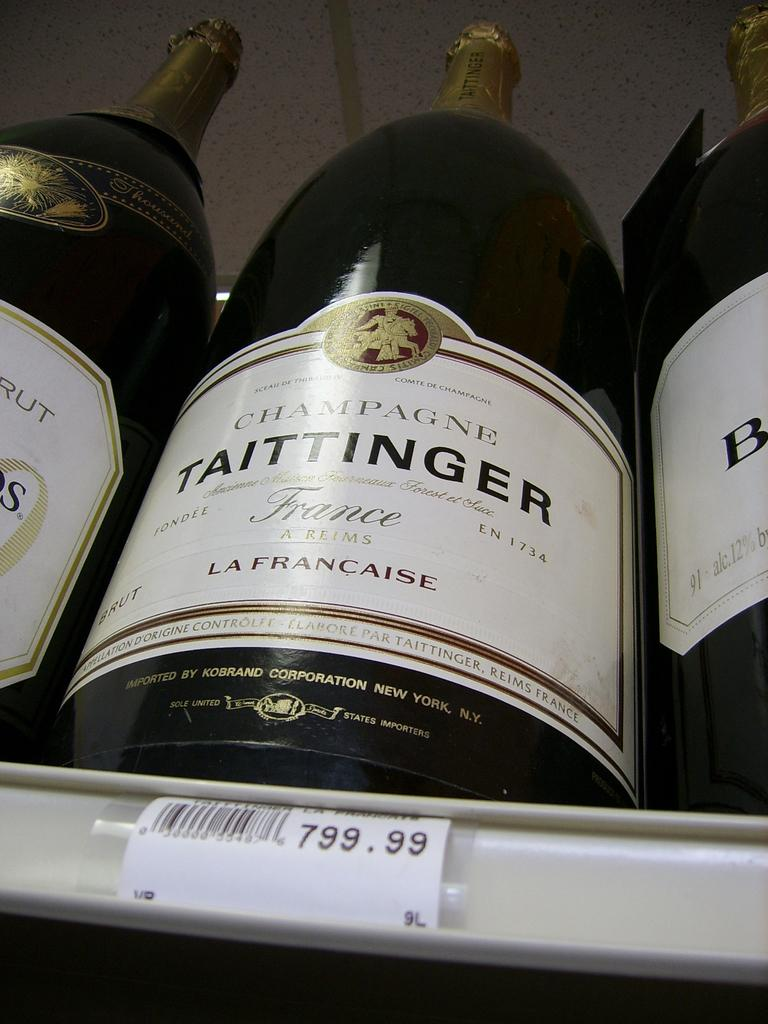Provide a one-sentence caption for the provided image. Three bottles of Taittinger champagne are on a shelf waiting to be sold. 